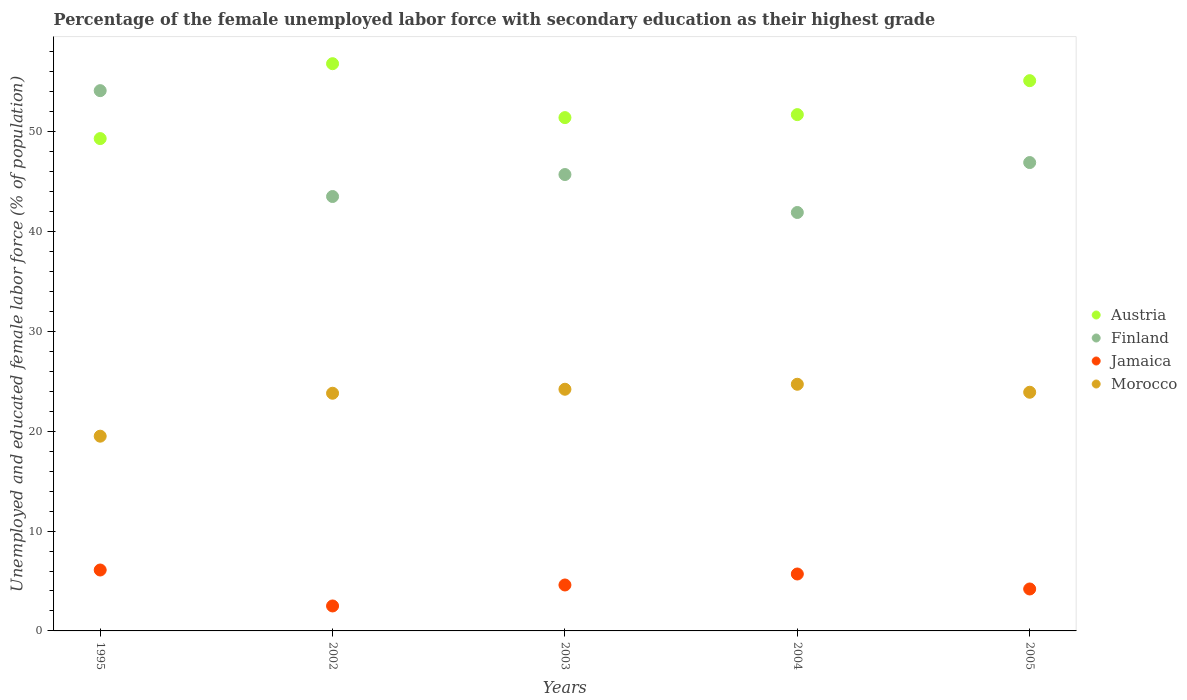What is the percentage of the unemployed female labor force with secondary education in Morocco in 2002?
Your response must be concise. 23.8. Across all years, what is the maximum percentage of the unemployed female labor force with secondary education in Morocco?
Your answer should be very brief. 24.7. Across all years, what is the minimum percentage of the unemployed female labor force with secondary education in Finland?
Give a very brief answer. 41.9. In which year was the percentage of the unemployed female labor force with secondary education in Jamaica minimum?
Provide a short and direct response. 2002. What is the total percentage of the unemployed female labor force with secondary education in Morocco in the graph?
Offer a terse response. 116.1. What is the difference between the percentage of the unemployed female labor force with secondary education in Morocco in 1995 and that in 2002?
Your response must be concise. -4.3. What is the difference between the percentage of the unemployed female labor force with secondary education in Jamaica in 2003 and the percentage of the unemployed female labor force with secondary education in Finland in 1995?
Provide a succinct answer. -49.5. What is the average percentage of the unemployed female labor force with secondary education in Austria per year?
Offer a terse response. 52.86. In the year 2003, what is the difference between the percentage of the unemployed female labor force with secondary education in Finland and percentage of the unemployed female labor force with secondary education in Austria?
Make the answer very short. -5.7. What is the ratio of the percentage of the unemployed female labor force with secondary education in Morocco in 2002 to that in 2004?
Offer a very short reply. 0.96. Is the percentage of the unemployed female labor force with secondary education in Austria in 1995 less than that in 2002?
Ensure brevity in your answer.  Yes. What is the difference between the highest and the second highest percentage of the unemployed female labor force with secondary education in Jamaica?
Your answer should be very brief. 0.4. What is the difference between the highest and the lowest percentage of the unemployed female labor force with secondary education in Austria?
Your answer should be compact. 7.5. Is the sum of the percentage of the unemployed female labor force with secondary education in Morocco in 2003 and 2004 greater than the maximum percentage of the unemployed female labor force with secondary education in Finland across all years?
Provide a short and direct response. No. Is it the case that in every year, the sum of the percentage of the unemployed female labor force with secondary education in Austria and percentage of the unemployed female labor force with secondary education in Morocco  is greater than the sum of percentage of the unemployed female labor force with secondary education in Jamaica and percentage of the unemployed female labor force with secondary education in Finland?
Provide a succinct answer. No. Is the percentage of the unemployed female labor force with secondary education in Austria strictly less than the percentage of the unemployed female labor force with secondary education in Finland over the years?
Give a very brief answer. No. How many dotlines are there?
Ensure brevity in your answer.  4. Where does the legend appear in the graph?
Offer a very short reply. Center right. How many legend labels are there?
Keep it short and to the point. 4. How are the legend labels stacked?
Your answer should be very brief. Vertical. What is the title of the graph?
Offer a very short reply. Percentage of the female unemployed labor force with secondary education as their highest grade. What is the label or title of the X-axis?
Offer a terse response. Years. What is the label or title of the Y-axis?
Provide a succinct answer. Unemployed and educated female labor force (% of population). What is the Unemployed and educated female labor force (% of population) in Austria in 1995?
Give a very brief answer. 49.3. What is the Unemployed and educated female labor force (% of population) of Finland in 1995?
Your answer should be compact. 54.1. What is the Unemployed and educated female labor force (% of population) in Jamaica in 1995?
Your answer should be compact. 6.1. What is the Unemployed and educated female labor force (% of population) of Morocco in 1995?
Make the answer very short. 19.5. What is the Unemployed and educated female labor force (% of population) in Austria in 2002?
Your answer should be compact. 56.8. What is the Unemployed and educated female labor force (% of population) of Finland in 2002?
Your answer should be compact. 43.5. What is the Unemployed and educated female labor force (% of population) of Morocco in 2002?
Your answer should be very brief. 23.8. What is the Unemployed and educated female labor force (% of population) in Austria in 2003?
Your answer should be very brief. 51.4. What is the Unemployed and educated female labor force (% of population) of Finland in 2003?
Give a very brief answer. 45.7. What is the Unemployed and educated female labor force (% of population) in Jamaica in 2003?
Your answer should be compact. 4.6. What is the Unemployed and educated female labor force (% of population) in Morocco in 2003?
Offer a very short reply. 24.2. What is the Unemployed and educated female labor force (% of population) of Austria in 2004?
Provide a succinct answer. 51.7. What is the Unemployed and educated female labor force (% of population) of Finland in 2004?
Give a very brief answer. 41.9. What is the Unemployed and educated female labor force (% of population) of Jamaica in 2004?
Give a very brief answer. 5.7. What is the Unemployed and educated female labor force (% of population) in Morocco in 2004?
Offer a terse response. 24.7. What is the Unemployed and educated female labor force (% of population) of Austria in 2005?
Make the answer very short. 55.1. What is the Unemployed and educated female labor force (% of population) in Finland in 2005?
Your answer should be very brief. 46.9. What is the Unemployed and educated female labor force (% of population) in Jamaica in 2005?
Your answer should be compact. 4.2. What is the Unemployed and educated female labor force (% of population) of Morocco in 2005?
Ensure brevity in your answer.  23.9. Across all years, what is the maximum Unemployed and educated female labor force (% of population) of Austria?
Offer a terse response. 56.8. Across all years, what is the maximum Unemployed and educated female labor force (% of population) of Finland?
Your response must be concise. 54.1. Across all years, what is the maximum Unemployed and educated female labor force (% of population) of Jamaica?
Offer a terse response. 6.1. Across all years, what is the maximum Unemployed and educated female labor force (% of population) of Morocco?
Offer a terse response. 24.7. Across all years, what is the minimum Unemployed and educated female labor force (% of population) in Austria?
Your response must be concise. 49.3. Across all years, what is the minimum Unemployed and educated female labor force (% of population) in Finland?
Your response must be concise. 41.9. Across all years, what is the minimum Unemployed and educated female labor force (% of population) of Jamaica?
Your response must be concise. 2.5. Across all years, what is the minimum Unemployed and educated female labor force (% of population) in Morocco?
Offer a very short reply. 19.5. What is the total Unemployed and educated female labor force (% of population) of Austria in the graph?
Ensure brevity in your answer.  264.3. What is the total Unemployed and educated female labor force (% of population) in Finland in the graph?
Make the answer very short. 232.1. What is the total Unemployed and educated female labor force (% of population) of Jamaica in the graph?
Your answer should be compact. 23.1. What is the total Unemployed and educated female labor force (% of population) of Morocco in the graph?
Keep it short and to the point. 116.1. What is the difference between the Unemployed and educated female labor force (% of population) of Finland in 1995 and that in 2002?
Your answer should be very brief. 10.6. What is the difference between the Unemployed and educated female labor force (% of population) in Morocco in 1995 and that in 2002?
Give a very brief answer. -4.3. What is the difference between the Unemployed and educated female labor force (% of population) of Morocco in 1995 and that in 2003?
Make the answer very short. -4.7. What is the difference between the Unemployed and educated female labor force (% of population) of Austria in 1995 and that in 2004?
Ensure brevity in your answer.  -2.4. What is the difference between the Unemployed and educated female labor force (% of population) in Morocco in 1995 and that in 2004?
Your response must be concise. -5.2. What is the difference between the Unemployed and educated female labor force (% of population) of Austria in 1995 and that in 2005?
Make the answer very short. -5.8. What is the difference between the Unemployed and educated female labor force (% of population) in Morocco in 2002 and that in 2003?
Keep it short and to the point. -0.4. What is the difference between the Unemployed and educated female labor force (% of population) in Austria in 2002 and that in 2004?
Offer a very short reply. 5.1. What is the difference between the Unemployed and educated female labor force (% of population) in Finland in 2002 and that in 2004?
Ensure brevity in your answer.  1.6. What is the difference between the Unemployed and educated female labor force (% of population) of Jamaica in 2002 and that in 2004?
Offer a terse response. -3.2. What is the difference between the Unemployed and educated female labor force (% of population) in Morocco in 2002 and that in 2004?
Provide a succinct answer. -0.9. What is the difference between the Unemployed and educated female labor force (% of population) in Austria in 2002 and that in 2005?
Ensure brevity in your answer.  1.7. What is the difference between the Unemployed and educated female labor force (% of population) in Morocco in 2002 and that in 2005?
Offer a terse response. -0.1. What is the difference between the Unemployed and educated female labor force (% of population) in Jamaica in 2003 and that in 2004?
Your response must be concise. -1.1. What is the difference between the Unemployed and educated female labor force (% of population) in Morocco in 2003 and that in 2004?
Offer a very short reply. -0.5. What is the difference between the Unemployed and educated female labor force (% of population) of Morocco in 2003 and that in 2005?
Your response must be concise. 0.3. What is the difference between the Unemployed and educated female labor force (% of population) of Austria in 2004 and that in 2005?
Make the answer very short. -3.4. What is the difference between the Unemployed and educated female labor force (% of population) in Morocco in 2004 and that in 2005?
Offer a very short reply. 0.8. What is the difference between the Unemployed and educated female labor force (% of population) in Austria in 1995 and the Unemployed and educated female labor force (% of population) in Jamaica in 2002?
Your response must be concise. 46.8. What is the difference between the Unemployed and educated female labor force (% of population) in Austria in 1995 and the Unemployed and educated female labor force (% of population) in Morocco in 2002?
Your answer should be compact. 25.5. What is the difference between the Unemployed and educated female labor force (% of population) in Finland in 1995 and the Unemployed and educated female labor force (% of population) in Jamaica in 2002?
Your answer should be compact. 51.6. What is the difference between the Unemployed and educated female labor force (% of population) in Finland in 1995 and the Unemployed and educated female labor force (% of population) in Morocco in 2002?
Make the answer very short. 30.3. What is the difference between the Unemployed and educated female labor force (% of population) of Jamaica in 1995 and the Unemployed and educated female labor force (% of population) of Morocco in 2002?
Make the answer very short. -17.7. What is the difference between the Unemployed and educated female labor force (% of population) in Austria in 1995 and the Unemployed and educated female labor force (% of population) in Jamaica in 2003?
Your answer should be compact. 44.7. What is the difference between the Unemployed and educated female labor force (% of population) in Austria in 1995 and the Unemployed and educated female labor force (% of population) in Morocco in 2003?
Your response must be concise. 25.1. What is the difference between the Unemployed and educated female labor force (% of population) of Finland in 1995 and the Unemployed and educated female labor force (% of population) of Jamaica in 2003?
Your answer should be very brief. 49.5. What is the difference between the Unemployed and educated female labor force (% of population) in Finland in 1995 and the Unemployed and educated female labor force (% of population) in Morocco in 2003?
Offer a terse response. 29.9. What is the difference between the Unemployed and educated female labor force (% of population) of Jamaica in 1995 and the Unemployed and educated female labor force (% of population) of Morocco in 2003?
Make the answer very short. -18.1. What is the difference between the Unemployed and educated female labor force (% of population) in Austria in 1995 and the Unemployed and educated female labor force (% of population) in Finland in 2004?
Provide a short and direct response. 7.4. What is the difference between the Unemployed and educated female labor force (% of population) of Austria in 1995 and the Unemployed and educated female labor force (% of population) of Jamaica in 2004?
Keep it short and to the point. 43.6. What is the difference between the Unemployed and educated female labor force (% of population) in Austria in 1995 and the Unemployed and educated female labor force (% of population) in Morocco in 2004?
Offer a terse response. 24.6. What is the difference between the Unemployed and educated female labor force (% of population) of Finland in 1995 and the Unemployed and educated female labor force (% of population) of Jamaica in 2004?
Give a very brief answer. 48.4. What is the difference between the Unemployed and educated female labor force (% of population) of Finland in 1995 and the Unemployed and educated female labor force (% of population) of Morocco in 2004?
Keep it short and to the point. 29.4. What is the difference between the Unemployed and educated female labor force (% of population) of Jamaica in 1995 and the Unemployed and educated female labor force (% of population) of Morocco in 2004?
Give a very brief answer. -18.6. What is the difference between the Unemployed and educated female labor force (% of population) in Austria in 1995 and the Unemployed and educated female labor force (% of population) in Jamaica in 2005?
Provide a short and direct response. 45.1. What is the difference between the Unemployed and educated female labor force (% of population) in Austria in 1995 and the Unemployed and educated female labor force (% of population) in Morocco in 2005?
Your response must be concise. 25.4. What is the difference between the Unemployed and educated female labor force (% of population) of Finland in 1995 and the Unemployed and educated female labor force (% of population) of Jamaica in 2005?
Give a very brief answer. 49.9. What is the difference between the Unemployed and educated female labor force (% of population) of Finland in 1995 and the Unemployed and educated female labor force (% of population) of Morocco in 2005?
Provide a short and direct response. 30.2. What is the difference between the Unemployed and educated female labor force (% of population) in Jamaica in 1995 and the Unemployed and educated female labor force (% of population) in Morocco in 2005?
Your answer should be very brief. -17.8. What is the difference between the Unemployed and educated female labor force (% of population) of Austria in 2002 and the Unemployed and educated female labor force (% of population) of Jamaica in 2003?
Offer a very short reply. 52.2. What is the difference between the Unemployed and educated female labor force (% of population) in Austria in 2002 and the Unemployed and educated female labor force (% of population) in Morocco in 2003?
Give a very brief answer. 32.6. What is the difference between the Unemployed and educated female labor force (% of population) in Finland in 2002 and the Unemployed and educated female labor force (% of population) in Jamaica in 2003?
Keep it short and to the point. 38.9. What is the difference between the Unemployed and educated female labor force (% of population) in Finland in 2002 and the Unemployed and educated female labor force (% of population) in Morocco in 2003?
Give a very brief answer. 19.3. What is the difference between the Unemployed and educated female labor force (% of population) of Jamaica in 2002 and the Unemployed and educated female labor force (% of population) of Morocco in 2003?
Ensure brevity in your answer.  -21.7. What is the difference between the Unemployed and educated female labor force (% of population) in Austria in 2002 and the Unemployed and educated female labor force (% of population) in Finland in 2004?
Keep it short and to the point. 14.9. What is the difference between the Unemployed and educated female labor force (% of population) of Austria in 2002 and the Unemployed and educated female labor force (% of population) of Jamaica in 2004?
Offer a terse response. 51.1. What is the difference between the Unemployed and educated female labor force (% of population) of Austria in 2002 and the Unemployed and educated female labor force (% of population) of Morocco in 2004?
Offer a terse response. 32.1. What is the difference between the Unemployed and educated female labor force (% of population) in Finland in 2002 and the Unemployed and educated female labor force (% of population) in Jamaica in 2004?
Ensure brevity in your answer.  37.8. What is the difference between the Unemployed and educated female labor force (% of population) in Jamaica in 2002 and the Unemployed and educated female labor force (% of population) in Morocco in 2004?
Your answer should be compact. -22.2. What is the difference between the Unemployed and educated female labor force (% of population) in Austria in 2002 and the Unemployed and educated female labor force (% of population) in Jamaica in 2005?
Your answer should be compact. 52.6. What is the difference between the Unemployed and educated female labor force (% of population) in Austria in 2002 and the Unemployed and educated female labor force (% of population) in Morocco in 2005?
Make the answer very short. 32.9. What is the difference between the Unemployed and educated female labor force (% of population) of Finland in 2002 and the Unemployed and educated female labor force (% of population) of Jamaica in 2005?
Offer a terse response. 39.3. What is the difference between the Unemployed and educated female labor force (% of population) in Finland in 2002 and the Unemployed and educated female labor force (% of population) in Morocco in 2005?
Provide a short and direct response. 19.6. What is the difference between the Unemployed and educated female labor force (% of population) of Jamaica in 2002 and the Unemployed and educated female labor force (% of population) of Morocco in 2005?
Make the answer very short. -21.4. What is the difference between the Unemployed and educated female labor force (% of population) of Austria in 2003 and the Unemployed and educated female labor force (% of population) of Finland in 2004?
Ensure brevity in your answer.  9.5. What is the difference between the Unemployed and educated female labor force (% of population) in Austria in 2003 and the Unemployed and educated female labor force (% of population) in Jamaica in 2004?
Your answer should be compact. 45.7. What is the difference between the Unemployed and educated female labor force (% of population) in Austria in 2003 and the Unemployed and educated female labor force (% of population) in Morocco in 2004?
Provide a succinct answer. 26.7. What is the difference between the Unemployed and educated female labor force (% of population) of Finland in 2003 and the Unemployed and educated female labor force (% of population) of Jamaica in 2004?
Your response must be concise. 40. What is the difference between the Unemployed and educated female labor force (% of population) in Jamaica in 2003 and the Unemployed and educated female labor force (% of population) in Morocco in 2004?
Your answer should be very brief. -20.1. What is the difference between the Unemployed and educated female labor force (% of population) of Austria in 2003 and the Unemployed and educated female labor force (% of population) of Jamaica in 2005?
Keep it short and to the point. 47.2. What is the difference between the Unemployed and educated female labor force (% of population) in Austria in 2003 and the Unemployed and educated female labor force (% of population) in Morocco in 2005?
Keep it short and to the point. 27.5. What is the difference between the Unemployed and educated female labor force (% of population) of Finland in 2003 and the Unemployed and educated female labor force (% of population) of Jamaica in 2005?
Make the answer very short. 41.5. What is the difference between the Unemployed and educated female labor force (% of population) of Finland in 2003 and the Unemployed and educated female labor force (% of population) of Morocco in 2005?
Your answer should be compact. 21.8. What is the difference between the Unemployed and educated female labor force (% of population) in Jamaica in 2003 and the Unemployed and educated female labor force (% of population) in Morocco in 2005?
Offer a terse response. -19.3. What is the difference between the Unemployed and educated female labor force (% of population) of Austria in 2004 and the Unemployed and educated female labor force (% of population) of Finland in 2005?
Offer a very short reply. 4.8. What is the difference between the Unemployed and educated female labor force (% of population) in Austria in 2004 and the Unemployed and educated female labor force (% of population) in Jamaica in 2005?
Ensure brevity in your answer.  47.5. What is the difference between the Unemployed and educated female labor force (% of population) in Austria in 2004 and the Unemployed and educated female labor force (% of population) in Morocco in 2005?
Your answer should be very brief. 27.8. What is the difference between the Unemployed and educated female labor force (% of population) in Finland in 2004 and the Unemployed and educated female labor force (% of population) in Jamaica in 2005?
Offer a terse response. 37.7. What is the difference between the Unemployed and educated female labor force (% of population) of Jamaica in 2004 and the Unemployed and educated female labor force (% of population) of Morocco in 2005?
Your answer should be compact. -18.2. What is the average Unemployed and educated female labor force (% of population) in Austria per year?
Ensure brevity in your answer.  52.86. What is the average Unemployed and educated female labor force (% of population) in Finland per year?
Your answer should be compact. 46.42. What is the average Unemployed and educated female labor force (% of population) of Jamaica per year?
Make the answer very short. 4.62. What is the average Unemployed and educated female labor force (% of population) in Morocco per year?
Make the answer very short. 23.22. In the year 1995, what is the difference between the Unemployed and educated female labor force (% of population) of Austria and Unemployed and educated female labor force (% of population) of Jamaica?
Provide a short and direct response. 43.2. In the year 1995, what is the difference between the Unemployed and educated female labor force (% of population) in Austria and Unemployed and educated female labor force (% of population) in Morocco?
Keep it short and to the point. 29.8. In the year 1995, what is the difference between the Unemployed and educated female labor force (% of population) in Finland and Unemployed and educated female labor force (% of population) in Morocco?
Keep it short and to the point. 34.6. In the year 2002, what is the difference between the Unemployed and educated female labor force (% of population) in Austria and Unemployed and educated female labor force (% of population) in Jamaica?
Keep it short and to the point. 54.3. In the year 2002, what is the difference between the Unemployed and educated female labor force (% of population) of Austria and Unemployed and educated female labor force (% of population) of Morocco?
Offer a terse response. 33. In the year 2002, what is the difference between the Unemployed and educated female labor force (% of population) in Jamaica and Unemployed and educated female labor force (% of population) in Morocco?
Make the answer very short. -21.3. In the year 2003, what is the difference between the Unemployed and educated female labor force (% of population) of Austria and Unemployed and educated female labor force (% of population) of Jamaica?
Offer a very short reply. 46.8. In the year 2003, what is the difference between the Unemployed and educated female labor force (% of population) in Austria and Unemployed and educated female labor force (% of population) in Morocco?
Provide a succinct answer. 27.2. In the year 2003, what is the difference between the Unemployed and educated female labor force (% of population) in Finland and Unemployed and educated female labor force (% of population) in Jamaica?
Keep it short and to the point. 41.1. In the year 2003, what is the difference between the Unemployed and educated female labor force (% of population) of Jamaica and Unemployed and educated female labor force (% of population) of Morocco?
Keep it short and to the point. -19.6. In the year 2004, what is the difference between the Unemployed and educated female labor force (% of population) in Austria and Unemployed and educated female labor force (% of population) in Finland?
Your answer should be very brief. 9.8. In the year 2004, what is the difference between the Unemployed and educated female labor force (% of population) in Finland and Unemployed and educated female labor force (% of population) in Jamaica?
Give a very brief answer. 36.2. In the year 2004, what is the difference between the Unemployed and educated female labor force (% of population) in Jamaica and Unemployed and educated female labor force (% of population) in Morocco?
Your answer should be very brief. -19. In the year 2005, what is the difference between the Unemployed and educated female labor force (% of population) of Austria and Unemployed and educated female labor force (% of population) of Finland?
Offer a very short reply. 8.2. In the year 2005, what is the difference between the Unemployed and educated female labor force (% of population) of Austria and Unemployed and educated female labor force (% of population) of Jamaica?
Your answer should be very brief. 50.9. In the year 2005, what is the difference between the Unemployed and educated female labor force (% of population) of Austria and Unemployed and educated female labor force (% of population) of Morocco?
Offer a very short reply. 31.2. In the year 2005, what is the difference between the Unemployed and educated female labor force (% of population) of Finland and Unemployed and educated female labor force (% of population) of Jamaica?
Keep it short and to the point. 42.7. In the year 2005, what is the difference between the Unemployed and educated female labor force (% of population) of Finland and Unemployed and educated female labor force (% of population) of Morocco?
Keep it short and to the point. 23. In the year 2005, what is the difference between the Unemployed and educated female labor force (% of population) of Jamaica and Unemployed and educated female labor force (% of population) of Morocco?
Provide a succinct answer. -19.7. What is the ratio of the Unemployed and educated female labor force (% of population) in Austria in 1995 to that in 2002?
Keep it short and to the point. 0.87. What is the ratio of the Unemployed and educated female labor force (% of population) in Finland in 1995 to that in 2002?
Offer a very short reply. 1.24. What is the ratio of the Unemployed and educated female labor force (% of population) of Jamaica in 1995 to that in 2002?
Provide a succinct answer. 2.44. What is the ratio of the Unemployed and educated female labor force (% of population) of Morocco in 1995 to that in 2002?
Your response must be concise. 0.82. What is the ratio of the Unemployed and educated female labor force (% of population) in Austria in 1995 to that in 2003?
Your answer should be compact. 0.96. What is the ratio of the Unemployed and educated female labor force (% of population) in Finland in 1995 to that in 2003?
Provide a succinct answer. 1.18. What is the ratio of the Unemployed and educated female labor force (% of population) in Jamaica in 1995 to that in 2003?
Ensure brevity in your answer.  1.33. What is the ratio of the Unemployed and educated female labor force (% of population) of Morocco in 1995 to that in 2003?
Give a very brief answer. 0.81. What is the ratio of the Unemployed and educated female labor force (% of population) of Austria in 1995 to that in 2004?
Give a very brief answer. 0.95. What is the ratio of the Unemployed and educated female labor force (% of population) of Finland in 1995 to that in 2004?
Your answer should be compact. 1.29. What is the ratio of the Unemployed and educated female labor force (% of population) in Jamaica in 1995 to that in 2004?
Your answer should be very brief. 1.07. What is the ratio of the Unemployed and educated female labor force (% of population) in Morocco in 1995 to that in 2004?
Make the answer very short. 0.79. What is the ratio of the Unemployed and educated female labor force (% of population) of Austria in 1995 to that in 2005?
Offer a very short reply. 0.89. What is the ratio of the Unemployed and educated female labor force (% of population) in Finland in 1995 to that in 2005?
Your response must be concise. 1.15. What is the ratio of the Unemployed and educated female labor force (% of population) of Jamaica in 1995 to that in 2005?
Keep it short and to the point. 1.45. What is the ratio of the Unemployed and educated female labor force (% of population) of Morocco in 1995 to that in 2005?
Offer a very short reply. 0.82. What is the ratio of the Unemployed and educated female labor force (% of population) in Austria in 2002 to that in 2003?
Your response must be concise. 1.11. What is the ratio of the Unemployed and educated female labor force (% of population) in Finland in 2002 to that in 2003?
Your response must be concise. 0.95. What is the ratio of the Unemployed and educated female labor force (% of population) of Jamaica in 2002 to that in 2003?
Ensure brevity in your answer.  0.54. What is the ratio of the Unemployed and educated female labor force (% of population) of Morocco in 2002 to that in 2003?
Offer a very short reply. 0.98. What is the ratio of the Unemployed and educated female labor force (% of population) in Austria in 2002 to that in 2004?
Make the answer very short. 1.1. What is the ratio of the Unemployed and educated female labor force (% of population) of Finland in 2002 to that in 2004?
Ensure brevity in your answer.  1.04. What is the ratio of the Unemployed and educated female labor force (% of population) in Jamaica in 2002 to that in 2004?
Offer a terse response. 0.44. What is the ratio of the Unemployed and educated female labor force (% of population) in Morocco in 2002 to that in 2004?
Provide a short and direct response. 0.96. What is the ratio of the Unemployed and educated female labor force (% of population) of Austria in 2002 to that in 2005?
Provide a short and direct response. 1.03. What is the ratio of the Unemployed and educated female labor force (% of population) in Finland in 2002 to that in 2005?
Provide a succinct answer. 0.93. What is the ratio of the Unemployed and educated female labor force (% of population) of Jamaica in 2002 to that in 2005?
Make the answer very short. 0.6. What is the ratio of the Unemployed and educated female labor force (% of population) in Austria in 2003 to that in 2004?
Your answer should be compact. 0.99. What is the ratio of the Unemployed and educated female labor force (% of population) of Finland in 2003 to that in 2004?
Provide a short and direct response. 1.09. What is the ratio of the Unemployed and educated female labor force (% of population) of Jamaica in 2003 to that in 2004?
Give a very brief answer. 0.81. What is the ratio of the Unemployed and educated female labor force (% of population) in Morocco in 2003 to that in 2004?
Keep it short and to the point. 0.98. What is the ratio of the Unemployed and educated female labor force (% of population) in Austria in 2003 to that in 2005?
Offer a very short reply. 0.93. What is the ratio of the Unemployed and educated female labor force (% of population) in Finland in 2003 to that in 2005?
Make the answer very short. 0.97. What is the ratio of the Unemployed and educated female labor force (% of population) in Jamaica in 2003 to that in 2005?
Keep it short and to the point. 1.1. What is the ratio of the Unemployed and educated female labor force (% of population) in Morocco in 2003 to that in 2005?
Offer a terse response. 1.01. What is the ratio of the Unemployed and educated female labor force (% of population) of Austria in 2004 to that in 2005?
Your answer should be very brief. 0.94. What is the ratio of the Unemployed and educated female labor force (% of population) in Finland in 2004 to that in 2005?
Provide a succinct answer. 0.89. What is the ratio of the Unemployed and educated female labor force (% of population) of Jamaica in 2004 to that in 2005?
Offer a very short reply. 1.36. What is the ratio of the Unemployed and educated female labor force (% of population) of Morocco in 2004 to that in 2005?
Provide a short and direct response. 1.03. What is the difference between the highest and the second highest Unemployed and educated female labor force (% of population) of Austria?
Your answer should be very brief. 1.7. What is the difference between the highest and the second highest Unemployed and educated female labor force (% of population) of Finland?
Your answer should be very brief. 7.2. What is the difference between the highest and the second highest Unemployed and educated female labor force (% of population) of Morocco?
Your response must be concise. 0.5. What is the difference between the highest and the lowest Unemployed and educated female labor force (% of population) in Finland?
Keep it short and to the point. 12.2. What is the difference between the highest and the lowest Unemployed and educated female labor force (% of population) in Jamaica?
Offer a very short reply. 3.6. 